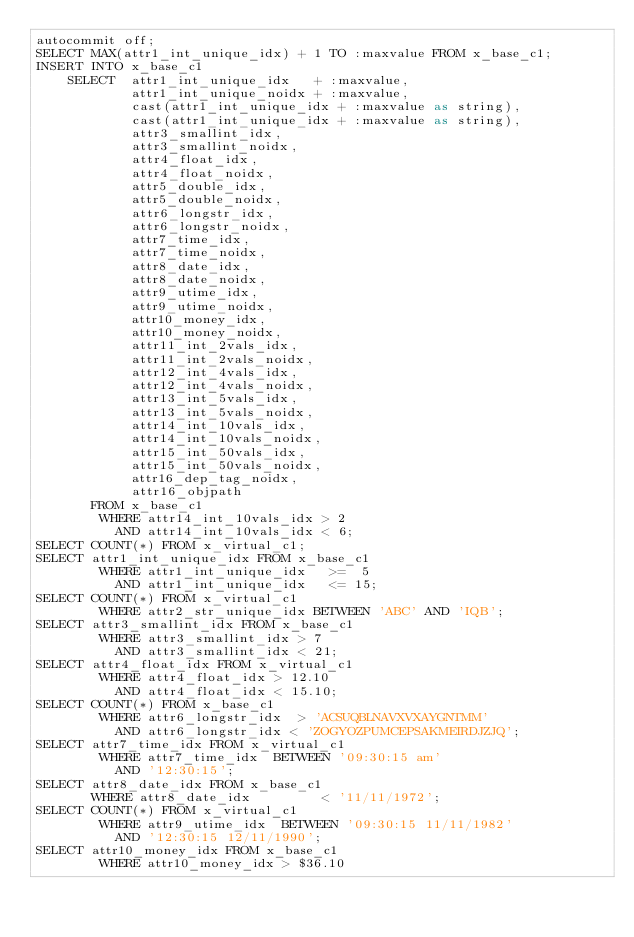Convert code to text. <code><loc_0><loc_0><loc_500><loc_500><_SQL_>autocommit off;
SELECT MAX(attr1_int_unique_idx) + 1 TO :maxvalue FROM x_base_c1;
INSERT INTO x_base_c1 
    SELECT  attr1_int_unique_idx   + :maxvalue, 
            attr1_int_unique_noidx + :maxvalue, 
            cast(attr1_int_unique_idx + :maxvalue as string),   
            cast(attr1_int_unique_idx + :maxvalue as string),   
            attr3_smallint_idx,       
            attr3_smallint_noidx,     
            attr4_float_idx,          
            attr4_float_noidx,        
            attr5_double_idx,         
            attr5_double_noidx,       
            attr6_longstr_idx,        
            attr6_longstr_noidx,      
            attr7_time_idx,           
            attr7_time_noidx,         
            attr8_date_idx,           
            attr8_date_noidx,         
            attr9_utime_idx,          
            attr9_utime_noidx,        
            attr10_money_idx,         
            attr10_money_noidx,       
            attr11_int_2vals_idx,     
            attr11_int_2vals_noidx,   
            attr12_int_4vals_idx,     
            attr12_int_4vals_noidx,   
            attr13_int_5vals_idx,     
            attr13_int_5vals_noidx,   
            attr14_int_10vals_idx,    
            attr14_int_10vals_noidx,  
            attr15_int_50vals_idx,    
            attr15_int_50vals_noidx,  
            attr16_dep_tag_noidx,     
            attr16_objpath            
       FROM x_base_c1
        WHERE attr14_int_10vals_idx > 2
          AND attr14_int_10vals_idx < 6;
SELECT COUNT(*) FROM x_virtual_c1;
SELECT attr1_int_unique_idx FROM x_base_c1
        WHERE attr1_int_unique_idx   >=  5
          AND attr1_int_unique_idx   <= 15;
SELECT COUNT(*) FROM x_virtual_c1
        WHERE attr2_str_unique_idx BETWEEN 'ABC' AND 'IQB';
SELECT attr3_smallint_idx FROM x_base_c1
        WHERE attr3_smallint_idx > 7
          AND attr3_smallint_idx < 21;
SELECT attr4_float_idx FROM x_virtual_c1
        WHERE attr4_float_idx > 12.10
          AND attr4_float_idx < 15.10;
SELECT COUNT(*) FROM x_base_c1
        WHERE attr6_longstr_idx  > 'ACSUQBLNAVXVXAYGNTMM'
          AND attr6_longstr_idx < 'ZOGYOZPUMCEPSAKMEIRDJZJQ';
SELECT attr7_time_idx FROM x_virtual_c1
        WHERE attr7_time_idx  BETWEEN '09:30:15 am' 
          AND '12:30:15';
SELECT attr8_date_idx FROM x_base_c1
       WHERE attr8_date_idx         < '11/11/1972';
SELECT COUNT(*) FROM x_virtual_c1
        WHERE attr9_utime_idx  BETWEEN '09:30:15 11/11/1982' 
          AND '12:30:15 12/11/1990';
SELECT attr10_money_idx FROM x_base_c1
        WHERE attr10_money_idx > $36.10</code> 